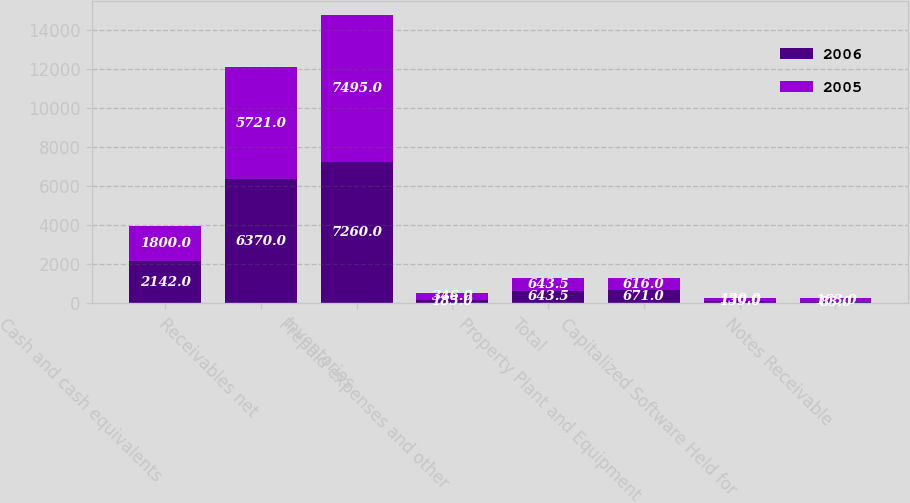<chart> <loc_0><loc_0><loc_500><loc_500><stacked_bar_chart><ecel><fcel>Cash and cash equivalents<fcel>Receivables net<fcel>Inventories<fcel>Prepaid expenses and other<fcel>Total<fcel>Property Plant and Equipment<fcel>Capitalized Software Held for<fcel>Notes Receivable<nl><fcel>2006<fcel>2142<fcel>6370<fcel>7260<fcel>185<fcel>643.5<fcel>671<fcel>139<fcel>83<nl><fcel>2005<fcel>1800<fcel>5721<fcel>7495<fcel>346<fcel>643.5<fcel>616<fcel>130<fcel>163<nl></chart> 